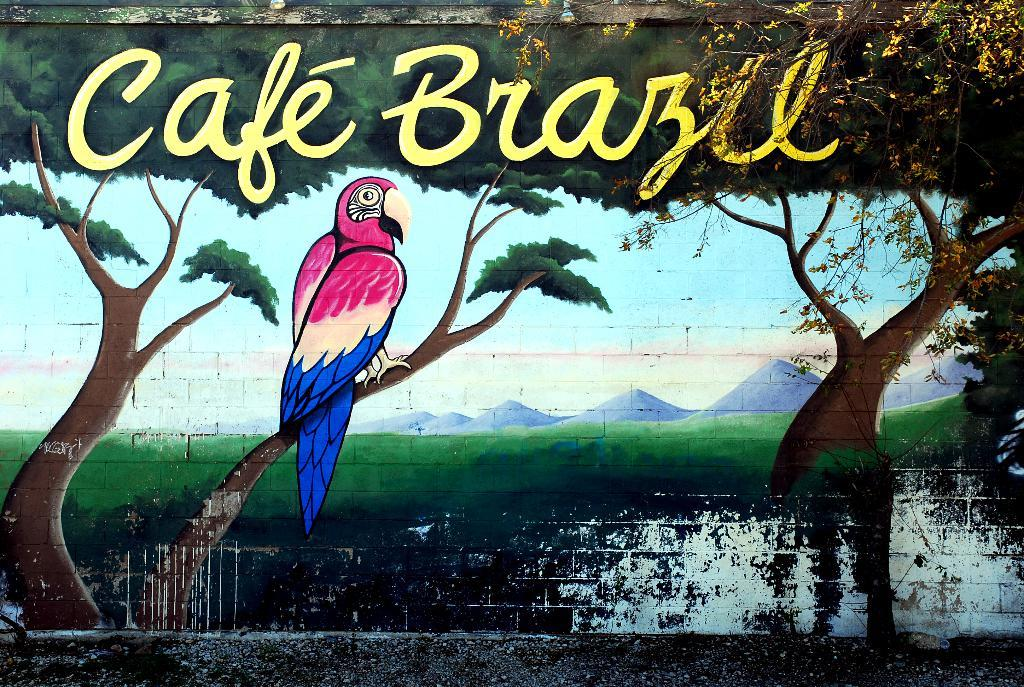What is depicted on the wall in the image? The image contains a depiction of a parrot and trees on a wall. Can you describe any other elements in the top right of the image? There is a branch in the top right of the image. What is present at the top of the image? There is text at the top of the image. How does the heat affect the parrot in the image? There is no indication of heat or temperature in the image, so it cannot be determined how it might affect the parrot. 